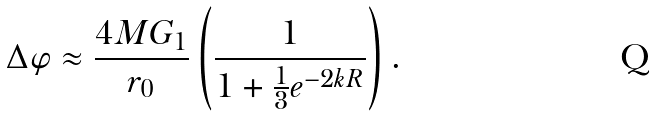<formula> <loc_0><loc_0><loc_500><loc_500>\Delta \varphi \approx \frac { 4 M G _ { 1 } } { r _ { 0 } } \left ( \frac { 1 } { 1 + \frac { 1 } { 3 } e ^ { - 2 k R } } \right ) .</formula> 